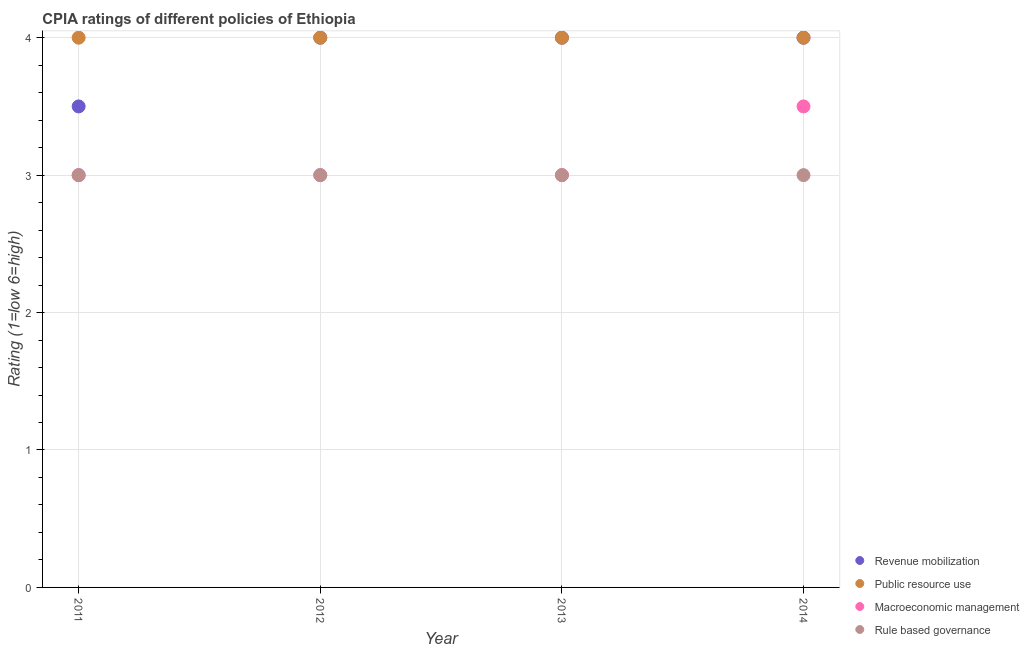How many different coloured dotlines are there?
Offer a terse response. 4. What is the cpia rating of rule based governance in 2014?
Ensure brevity in your answer.  3. Across all years, what is the maximum cpia rating of rule based governance?
Offer a very short reply. 3. In which year was the cpia rating of revenue mobilization minimum?
Provide a succinct answer. 2011. What is the difference between the cpia rating of public resource use in 2012 and that in 2013?
Ensure brevity in your answer.  0. In the year 2014, what is the difference between the cpia rating of public resource use and cpia rating of rule based governance?
Your answer should be very brief. 1. What is the ratio of the cpia rating of rule based governance in 2012 to that in 2013?
Your response must be concise. 1. What is the difference between the highest and the second highest cpia rating of macroeconomic management?
Make the answer very short. 0.5. What is the difference between the highest and the lowest cpia rating of revenue mobilization?
Your answer should be very brief. 0.5. Is the sum of the cpia rating of public resource use in 2011 and 2013 greater than the maximum cpia rating of macroeconomic management across all years?
Provide a short and direct response. Yes. Is it the case that in every year, the sum of the cpia rating of revenue mobilization and cpia rating of public resource use is greater than the sum of cpia rating of rule based governance and cpia rating of macroeconomic management?
Keep it short and to the point. Yes. Is it the case that in every year, the sum of the cpia rating of revenue mobilization and cpia rating of public resource use is greater than the cpia rating of macroeconomic management?
Provide a succinct answer. Yes. How many years are there in the graph?
Provide a succinct answer. 4. Are the values on the major ticks of Y-axis written in scientific E-notation?
Offer a terse response. No. Does the graph contain any zero values?
Offer a very short reply. No. How many legend labels are there?
Provide a short and direct response. 4. What is the title of the graph?
Make the answer very short. CPIA ratings of different policies of Ethiopia. What is the label or title of the Y-axis?
Make the answer very short. Rating (1=low 6=high). What is the Rating (1=low 6=high) of Revenue mobilization in 2011?
Ensure brevity in your answer.  3.5. What is the Rating (1=low 6=high) of Public resource use in 2011?
Provide a succinct answer. 4. What is the Rating (1=low 6=high) of Macroeconomic management in 2011?
Give a very brief answer. 3. What is the Rating (1=low 6=high) of Revenue mobilization in 2012?
Your answer should be compact. 4. What is the Rating (1=low 6=high) of Revenue mobilization in 2013?
Make the answer very short. 4. What is the Rating (1=low 6=high) in Rule based governance in 2013?
Your answer should be compact. 3. What is the Rating (1=low 6=high) of Macroeconomic management in 2014?
Offer a very short reply. 3.5. What is the Rating (1=low 6=high) in Rule based governance in 2014?
Your answer should be very brief. 3. Across all years, what is the maximum Rating (1=low 6=high) in Rule based governance?
Offer a terse response. 3. Across all years, what is the minimum Rating (1=low 6=high) of Rule based governance?
Provide a short and direct response. 3. What is the total Rating (1=low 6=high) of Public resource use in the graph?
Your answer should be compact. 16. What is the total Rating (1=low 6=high) of Macroeconomic management in the graph?
Your answer should be compact. 12.5. What is the total Rating (1=low 6=high) of Rule based governance in the graph?
Your response must be concise. 12. What is the difference between the Rating (1=low 6=high) in Rule based governance in 2011 and that in 2012?
Make the answer very short. 0. What is the difference between the Rating (1=low 6=high) in Revenue mobilization in 2011 and that in 2013?
Offer a terse response. -0.5. What is the difference between the Rating (1=low 6=high) in Public resource use in 2011 and that in 2013?
Give a very brief answer. 0. What is the difference between the Rating (1=low 6=high) of Rule based governance in 2011 and that in 2013?
Provide a succinct answer. 0. What is the difference between the Rating (1=low 6=high) of Rule based governance in 2011 and that in 2014?
Give a very brief answer. 0. What is the difference between the Rating (1=low 6=high) in Revenue mobilization in 2012 and that in 2013?
Provide a short and direct response. 0. What is the difference between the Rating (1=low 6=high) in Public resource use in 2012 and that in 2013?
Keep it short and to the point. 0. What is the difference between the Rating (1=low 6=high) in Macroeconomic management in 2012 and that in 2013?
Offer a terse response. 0. What is the difference between the Rating (1=low 6=high) of Revenue mobilization in 2012 and that in 2014?
Give a very brief answer. 0. What is the difference between the Rating (1=low 6=high) of Public resource use in 2012 and that in 2014?
Make the answer very short. 0. What is the difference between the Rating (1=low 6=high) in Macroeconomic management in 2013 and that in 2014?
Provide a short and direct response. -0.5. What is the difference between the Rating (1=low 6=high) of Revenue mobilization in 2011 and the Rating (1=low 6=high) of Rule based governance in 2012?
Ensure brevity in your answer.  0.5. What is the difference between the Rating (1=low 6=high) of Public resource use in 2011 and the Rating (1=low 6=high) of Macroeconomic management in 2012?
Keep it short and to the point. 1. What is the difference between the Rating (1=low 6=high) of Macroeconomic management in 2011 and the Rating (1=low 6=high) of Rule based governance in 2013?
Provide a short and direct response. 0. What is the difference between the Rating (1=low 6=high) of Revenue mobilization in 2011 and the Rating (1=low 6=high) of Rule based governance in 2014?
Your answer should be very brief. 0.5. What is the difference between the Rating (1=low 6=high) of Public resource use in 2011 and the Rating (1=low 6=high) of Rule based governance in 2014?
Your response must be concise. 1. What is the difference between the Rating (1=low 6=high) of Revenue mobilization in 2012 and the Rating (1=low 6=high) of Macroeconomic management in 2013?
Offer a very short reply. 1. What is the difference between the Rating (1=low 6=high) in Revenue mobilization in 2012 and the Rating (1=low 6=high) in Rule based governance in 2014?
Give a very brief answer. 1. What is the difference between the Rating (1=low 6=high) of Public resource use in 2012 and the Rating (1=low 6=high) of Rule based governance in 2014?
Give a very brief answer. 1. What is the difference between the Rating (1=low 6=high) in Macroeconomic management in 2012 and the Rating (1=low 6=high) in Rule based governance in 2014?
Offer a very short reply. 0. What is the difference between the Rating (1=low 6=high) of Revenue mobilization in 2013 and the Rating (1=low 6=high) of Public resource use in 2014?
Provide a succinct answer. 0. What is the difference between the Rating (1=low 6=high) in Revenue mobilization in 2013 and the Rating (1=low 6=high) in Rule based governance in 2014?
Keep it short and to the point. 1. What is the average Rating (1=low 6=high) in Revenue mobilization per year?
Provide a short and direct response. 3.88. What is the average Rating (1=low 6=high) in Macroeconomic management per year?
Provide a succinct answer. 3.12. What is the average Rating (1=low 6=high) in Rule based governance per year?
Offer a very short reply. 3. In the year 2011, what is the difference between the Rating (1=low 6=high) of Revenue mobilization and Rating (1=low 6=high) of Rule based governance?
Offer a terse response. 0.5. In the year 2011, what is the difference between the Rating (1=low 6=high) of Public resource use and Rating (1=low 6=high) of Macroeconomic management?
Make the answer very short. 1. In the year 2011, what is the difference between the Rating (1=low 6=high) of Public resource use and Rating (1=low 6=high) of Rule based governance?
Offer a very short reply. 1. In the year 2011, what is the difference between the Rating (1=low 6=high) in Macroeconomic management and Rating (1=low 6=high) in Rule based governance?
Ensure brevity in your answer.  0. In the year 2012, what is the difference between the Rating (1=low 6=high) in Revenue mobilization and Rating (1=low 6=high) in Macroeconomic management?
Make the answer very short. 1. In the year 2012, what is the difference between the Rating (1=low 6=high) of Revenue mobilization and Rating (1=low 6=high) of Rule based governance?
Ensure brevity in your answer.  1. In the year 2012, what is the difference between the Rating (1=low 6=high) in Public resource use and Rating (1=low 6=high) in Macroeconomic management?
Provide a succinct answer. 1. In the year 2012, what is the difference between the Rating (1=low 6=high) of Public resource use and Rating (1=low 6=high) of Rule based governance?
Ensure brevity in your answer.  1. In the year 2013, what is the difference between the Rating (1=low 6=high) of Revenue mobilization and Rating (1=low 6=high) of Public resource use?
Offer a terse response. 0. In the year 2013, what is the difference between the Rating (1=low 6=high) in Revenue mobilization and Rating (1=low 6=high) in Macroeconomic management?
Give a very brief answer. 1. In the year 2013, what is the difference between the Rating (1=low 6=high) in Macroeconomic management and Rating (1=low 6=high) in Rule based governance?
Keep it short and to the point. 0. In the year 2014, what is the difference between the Rating (1=low 6=high) in Revenue mobilization and Rating (1=low 6=high) in Rule based governance?
Give a very brief answer. 1. In the year 2014, what is the difference between the Rating (1=low 6=high) of Public resource use and Rating (1=low 6=high) of Macroeconomic management?
Your answer should be compact. 0.5. What is the ratio of the Rating (1=low 6=high) of Revenue mobilization in 2011 to that in 2013?
Your answer should be compact. 0.88. What is the ratio of the Rating (1=low 6=high) of Public resource use in 2011 to that in 2013?
Give a very brief answer. 1. What is the ratio of the Rating (1=low 6=high) of Macroeconomic management in 2011 to that in 2013?
Keep it short and to the point. 1. What is the ratio of the Rating (1=low 6=high) in Rule based governance in 2011 to that in 2013?
Offer a very short reply. 1. What is the ratio of the Rating (1=low 6=high) of Revenue mobilization in 2011 to that in 2014?
Offer a terse response. 0.88. What is the ratio of the Rating (1=low 6=high) in Public resource use in 2011 to that in 2014?
Ensure brevity in your answer.  1. What is the ratio of the Rating (1=low 6=high) in Revenue mobilization in 2012 to that in 2013?
Provide a succinct answer. 1. What is the ratio of the Rating (1=low 6=high) of Macroeconomic management in 2012 to that in 2013?
Your answer should be compact. 1. What is the ratio of the Rating (1=low 6=high) of Rule based governance in 2012 to that in 2013?
Your response must be concise. 1. What is the ratio of the Rating (1=low 6=high) in Macroeconomic management in 2012 to that in 2014?
Ensure brevity in your answer.  0.86. What is the ratio of the Rating (1=low 6=high) of Macroeconomic management in 2013 to that in 2014?
Keep it short and to the point. 0.86. What is the difference between the highest and the second highest Rating (1=low 6=high) in Public resource use?
Your response must be concise. 0. What is the difference between the highest and the second highest Rating (1=low 6=high) of Macroeconomic management?
Offer a very short reply. 0.5. What is the difference between the highest and the lowest Rating (1=low 6=high) of Public resource use?
Give a very brief answer. 0. What is the difference between the highest and the lowest Rating (1=low 6=high) in Macroeconomic management?
Give a very brief answer. 0.5. 